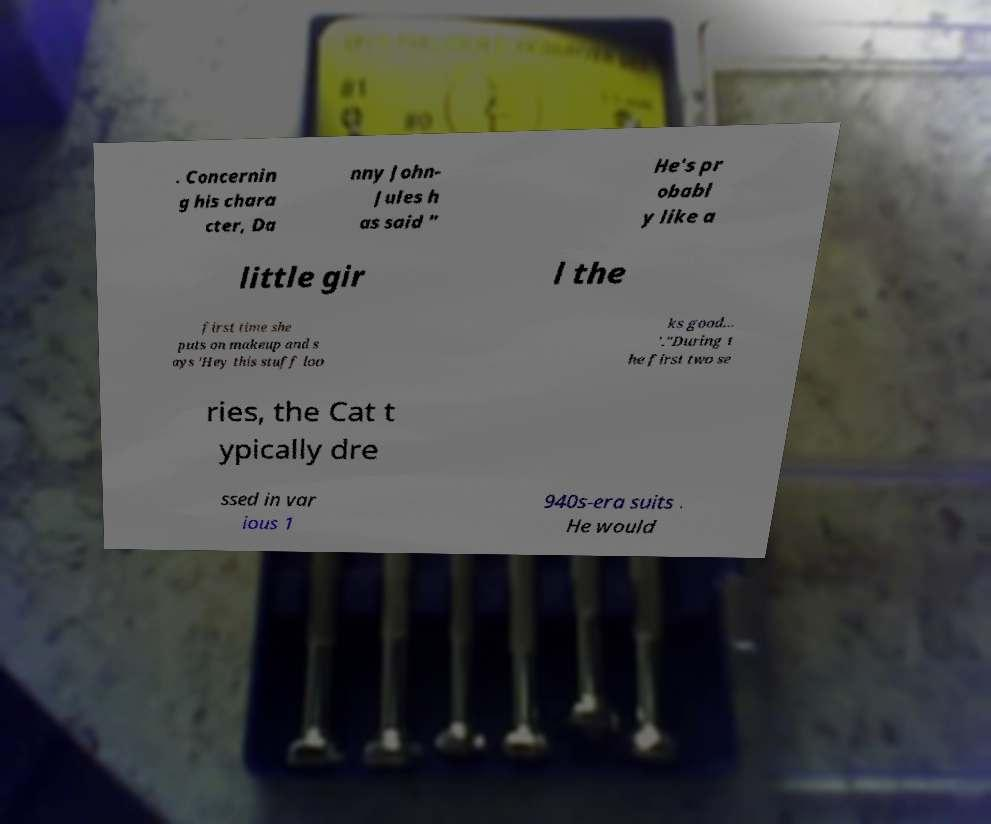Please identify and transcribe the text found in this image. . Concernin g his chara cter, Da nny John- Jules h as said " He's pr obabl y like a little gir l the first time she puts on makeup and s ays 'Hey this stuff loo ks good... '."During t he first two se ries, the Cat t ypically dre ssed in var ious 1 940s-era suits . He would 